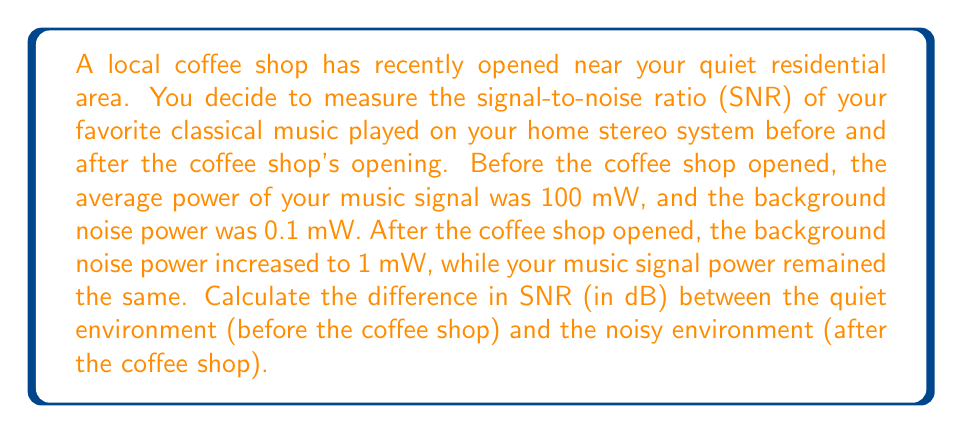Can you answer this question? To solve this problem, we need to follow these steps:

1. Calculate the SNR for the quiet environment (before the coffee shop)
2. Calculate the SNR for the noisy environment (after the coffee shop)
3. Find the difference between the two SNRs

Step 1: SNR for the quiet environment

The formula for SNR in decibels is:

$$ SNR_{dB} = 10 \log_{10}\left(\frac{P_{signal}}{P_{noise}}\right) $$

Where $P_{signal}$ is the signal power and $P_{noise}$ is the noise power.

For the quiet environment:
$P_{signal} = 100 \text{ mW}$
$P_{noise} = 0.1 \text{ mW}$

$$ SNR_{quiet} = 10 \log_{10}\left(\frac{100}{0.1}\right) = 10 \log_{10}(1000) = 30 \text{ dB} $$

Step 2: SNR for the noisy environment

For the noisy environment:
$P_{signal} = 100 \text{ mW}$ (unchanged)
$P_{noise} = 1 \text{ mW}$

$$ SNR_{noisy} = 10 \log_{10}\left(\frac{100}{1}\right) = 10 \log_{10}(100) = 20 \text{ dB} $$

Step 3: Difference in SNR

The difference in SNR is:

$$ \Delta SNR = SNR_{quiet} - SNR_{noisy} = 30 \text{ dB} - 20 \text{ dB} = 10 \text{ dB} $$
Answer: The difference in SNR between the quiet environment (before the coffee shop) and the noisy environment (after the coffee shop) is 10 dB. 